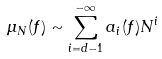<formula> <loc_0><loc_0><loc_500><loc_500>\mu _ { N } ( f ) \sim \sum _ { i = d - 1 } ^ { - \infty } a _ { i } ( f ) N ^ { i }</formula> 